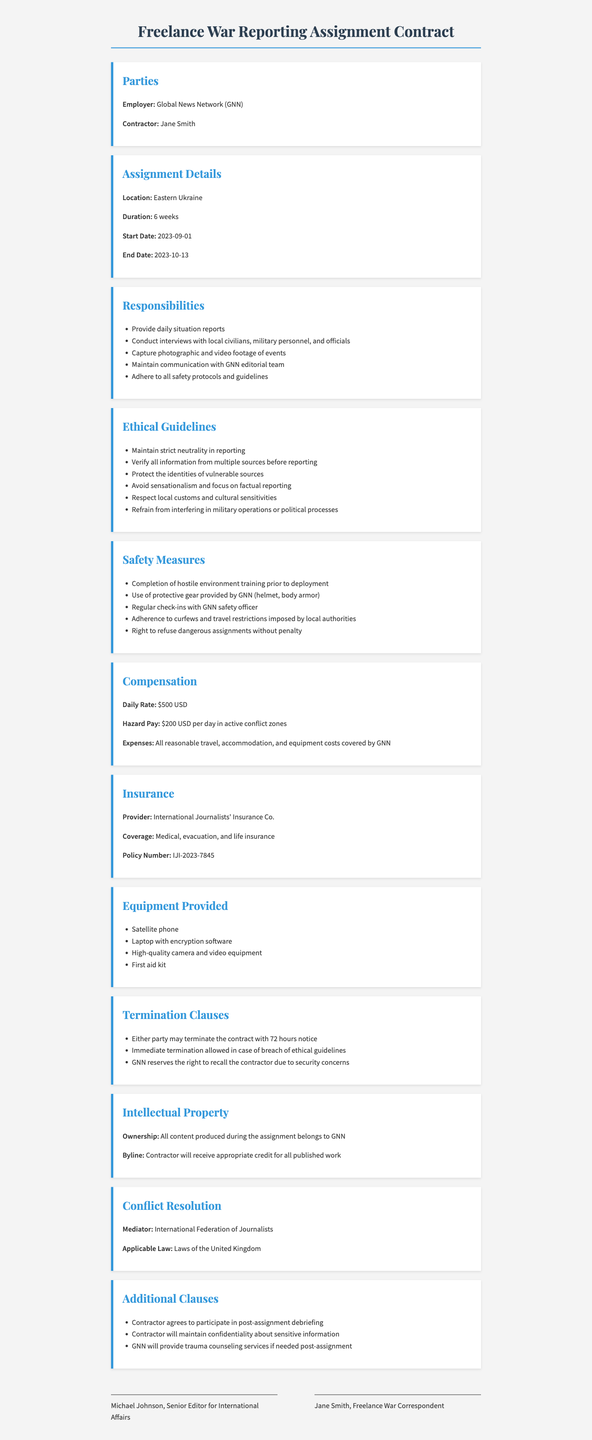What is the name of the employer? The employer is stated as Global News Network (GNN) in the document.
Answer: Global News Network (GNN) What is the assignment location? The document specifies that the assignment location is Eastern Ukraine.
Answer: Eastern Ukraine What is the daily rate of compensation? The document mentions that the daily rate of compensation is $500 USD.
Answer: $500 USD How long is the assignment duration? The duration of the assignment is specified as 6 weeks in the document.
Answer: 6 weeks What is the hazard pay per day? The document states that the hazard pay is $200 USD per day in active conflict zones.
Answer: $200 USD per day What type of training is needed before deployment? The document indicates that completion of hostile environment training is required prior to deployment.
Answer: Hostile environment training Who is responsible for mediation in conflict resolution? The document mentions the International Federation of Journalists as the mediator for conflict resolution.
Answer: International Federation of Journalists What is the right of the contractor regarding dangerous assignments? The contractor has the right to refuse dangerous assignments without penalty as stated in the document.
Answer: Right to refuse What happens in case of a breach of ethical guidelines? The document specifies that immediate termination is allowed in the event of a breach of ethical guidelines.
Answer: Immediate termination What insurance coverage is provided? The insurance coverage includes medical, evacuation, and life insurance as stated in the document.
Answer: Medical, evacuation, and life insurance 